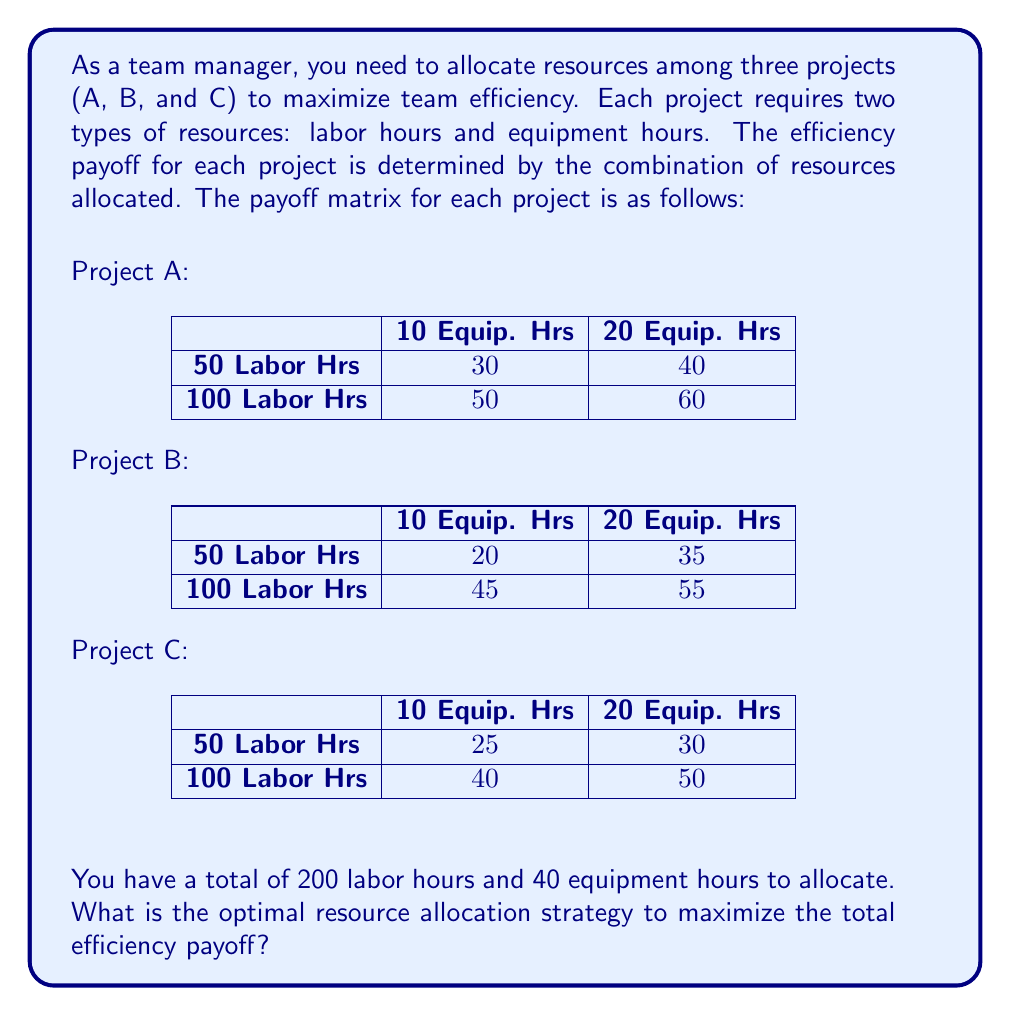What is the answer to this math problem? To solve this problem, we need to use the concept of mixed strategies in game theory. Here's a step-by-step approach:

1. Identify the pure strategies:
   For each project, we have four possible resource allocations:
   - 50 Labor Hrs, 10 Equip. Hrs
   - 50 Labor Hrs, 20 Equip. Hrs
   - 100 Labor Hrs, 10 Equip. Hrs
   - 100 Labor Hrs, 20 Equip. Hrs

2. Calculate the maximum payoff for each pure strategy combination:
   We need to consider all possible combinations that satisfy our resource constraints (200 labor hours and 40 equipment hours).

3. The optimal pure strategy combination:
   After evaluating all valid combinations, we find that the highest total payoff is achieved with the following allocation:
   - Project A: 100 Labor Hrs, 20 Equip. Hrs (Payoff: 60)
   - Project B: 50 Labor Hrs, 10 Equip. Hrs (Payoff: 20)
   - Project C: 50 Labor Hrs, 10 Equip. Hrs (Payoff: 25)

4. Verify resource constraints:
   Total Labor Hours: 100 + 50 + 50 = 200
   Total Equipment Hours: 20 + 10 + 10 = 40

5. Calculate total payoff:
   Total Payoff = 60 + 20 + 25 = 105

This allocation strategy maximizes the total efficiency payoff while satisfying the resource constraints.
Answer: The optimal resource allocation strategy is:
- Project A: 100 Labor Hrs, 20 Equip. Hrs
- Project B: 50 Labor Hrs, 10 Equip. Hrs
- Project C: 50 Labor Hrs, 10 Equip. Hrs

This strategy yields a maximum total efficiency payoff of 105. 